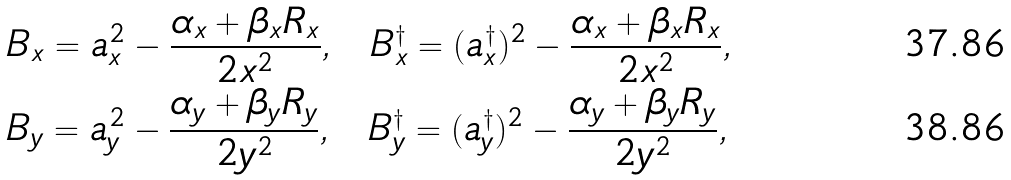Convert formula to latex. <formula><loc_0><loc_0><loc_500><loc_500>& B _ { x } = { a _ { x } ^ { 2 } } - \frac { \alpha _ { x } + \beta _ { x } R _ { x } } { 2 x ^ { 2 } } , \ \ B _ { x } ^ { \dagger } = ( a _ { x } ^ { \dagger } ) ^ { 2 } - \frac { \alpha _ { x } + \beta _ { x } R _ { x } } { 2 x ^ { 2 } } , \\ & B _ { y } = { a _ { y } ^ { 2 } } - \frac { \alpha _ { y } + \beta _ { y } R _ { y } } { 2 y ^ { 2 } } , \ \ B _ { y } ^ { \dagger } = { ( a _ { y } ^ { \dagger } ) ^ { 2 } } - \frac { \alpha _ { y } + \beta _ { y } R _ { y } } { 2 y ^ { 2 } } ,</formula> 